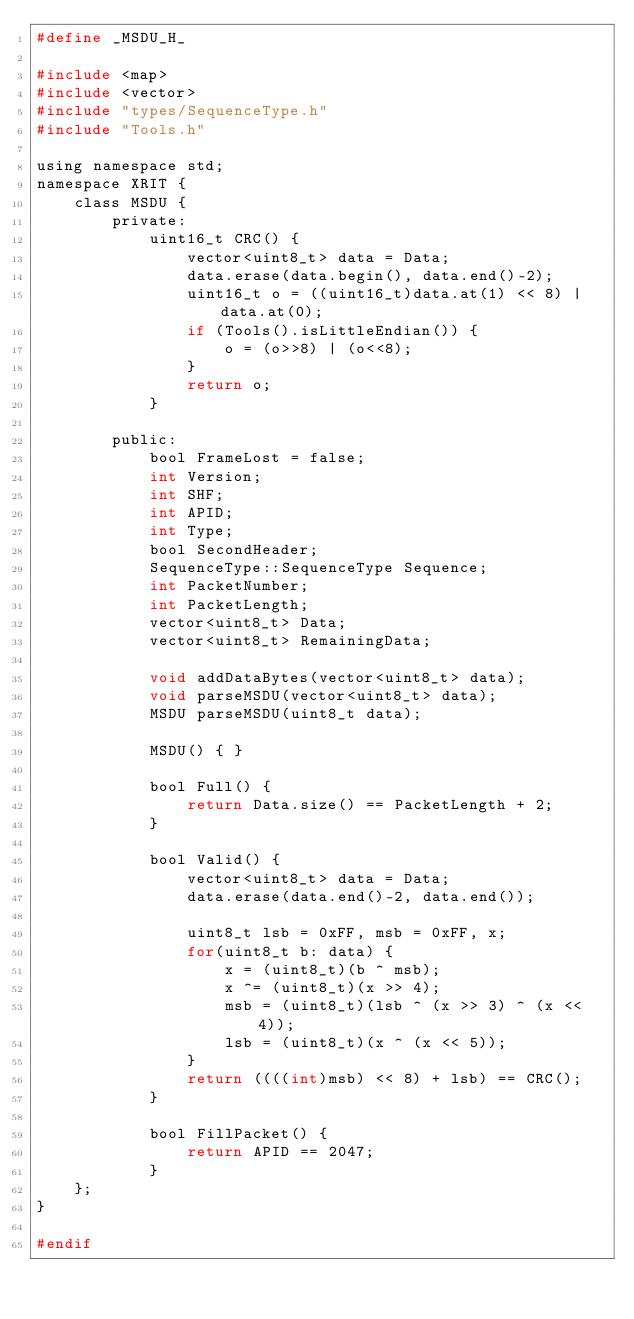<code> <loc_0><loc_0><loc_500><loc_500><_C_>#define _MSDU_H_

#include <map>
#include <vector>
#include "types/SequenceType.h"
#include "Tools.h"

using namespace std;
namespace XRIT {
    class MSDU {
        private:
            uint16_t CRC() {
                vector<uint8_t> data = Data;
                data.erase(data.begin(), data.end()-2);
                uint16_t o = ((uint16_t)data.at(1) << 8) | data.at(0);
                if (Tools().isLittleEndian()) {
                    o = (o>>8) | (o<<8);
                }
                return o;
            }

        public:
            bool FrameLost = false;
            int Version;
            int SHF;
            int APID;
            int Type;
            bool SecondHeader;
            SequenceType::SequenceType Sequence;
            int PacketNumber;
            int PacketLength;
            vector<uint8_t> Data;
            vector<uint8_t> RemainingData;

            void addDataBytes(vector<uint8_t> data);
            void parseMSDU(vector<uint8_t> data);
            MSDU parseMSDU(uint8_t data);

            MSDU() { }

            bool Full() { 
                return Data.size() == PacketLength + 2;
            }

            bool Valid() {
                vector<uint8_t> data = Data;
                data.erase(data.end()-2, data.end());

                uint8_t lsb = 0xFF, msb = 0xFF, x;
                for(uint8_t b: data) {
                    x = (uint8_t)(b ^ msb);
                    x ^= (uint8_t)(x >> 4);
                    msb = (uint8_t)(lsb ^ (x >> 3) ^ (x << 4));
                    lsb = (uint8_t)(x ^ (x << 5));
                }
                return ((((int)msb) << 8) + lsb) == CRC();
            }

            bool FillPacket() {
                return APID == 2047;
            }            
    };
}

#endif</code> 